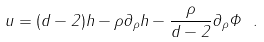Convert formula to latex. <formula><loc_0><loc_0><loc_500><loc_500>u = ( d - 2 ) h - \rho \partial _ { \rho } h - \frac { \rho } { d - 2 } \partial _ { \rho } \Phi \ .</formula> 